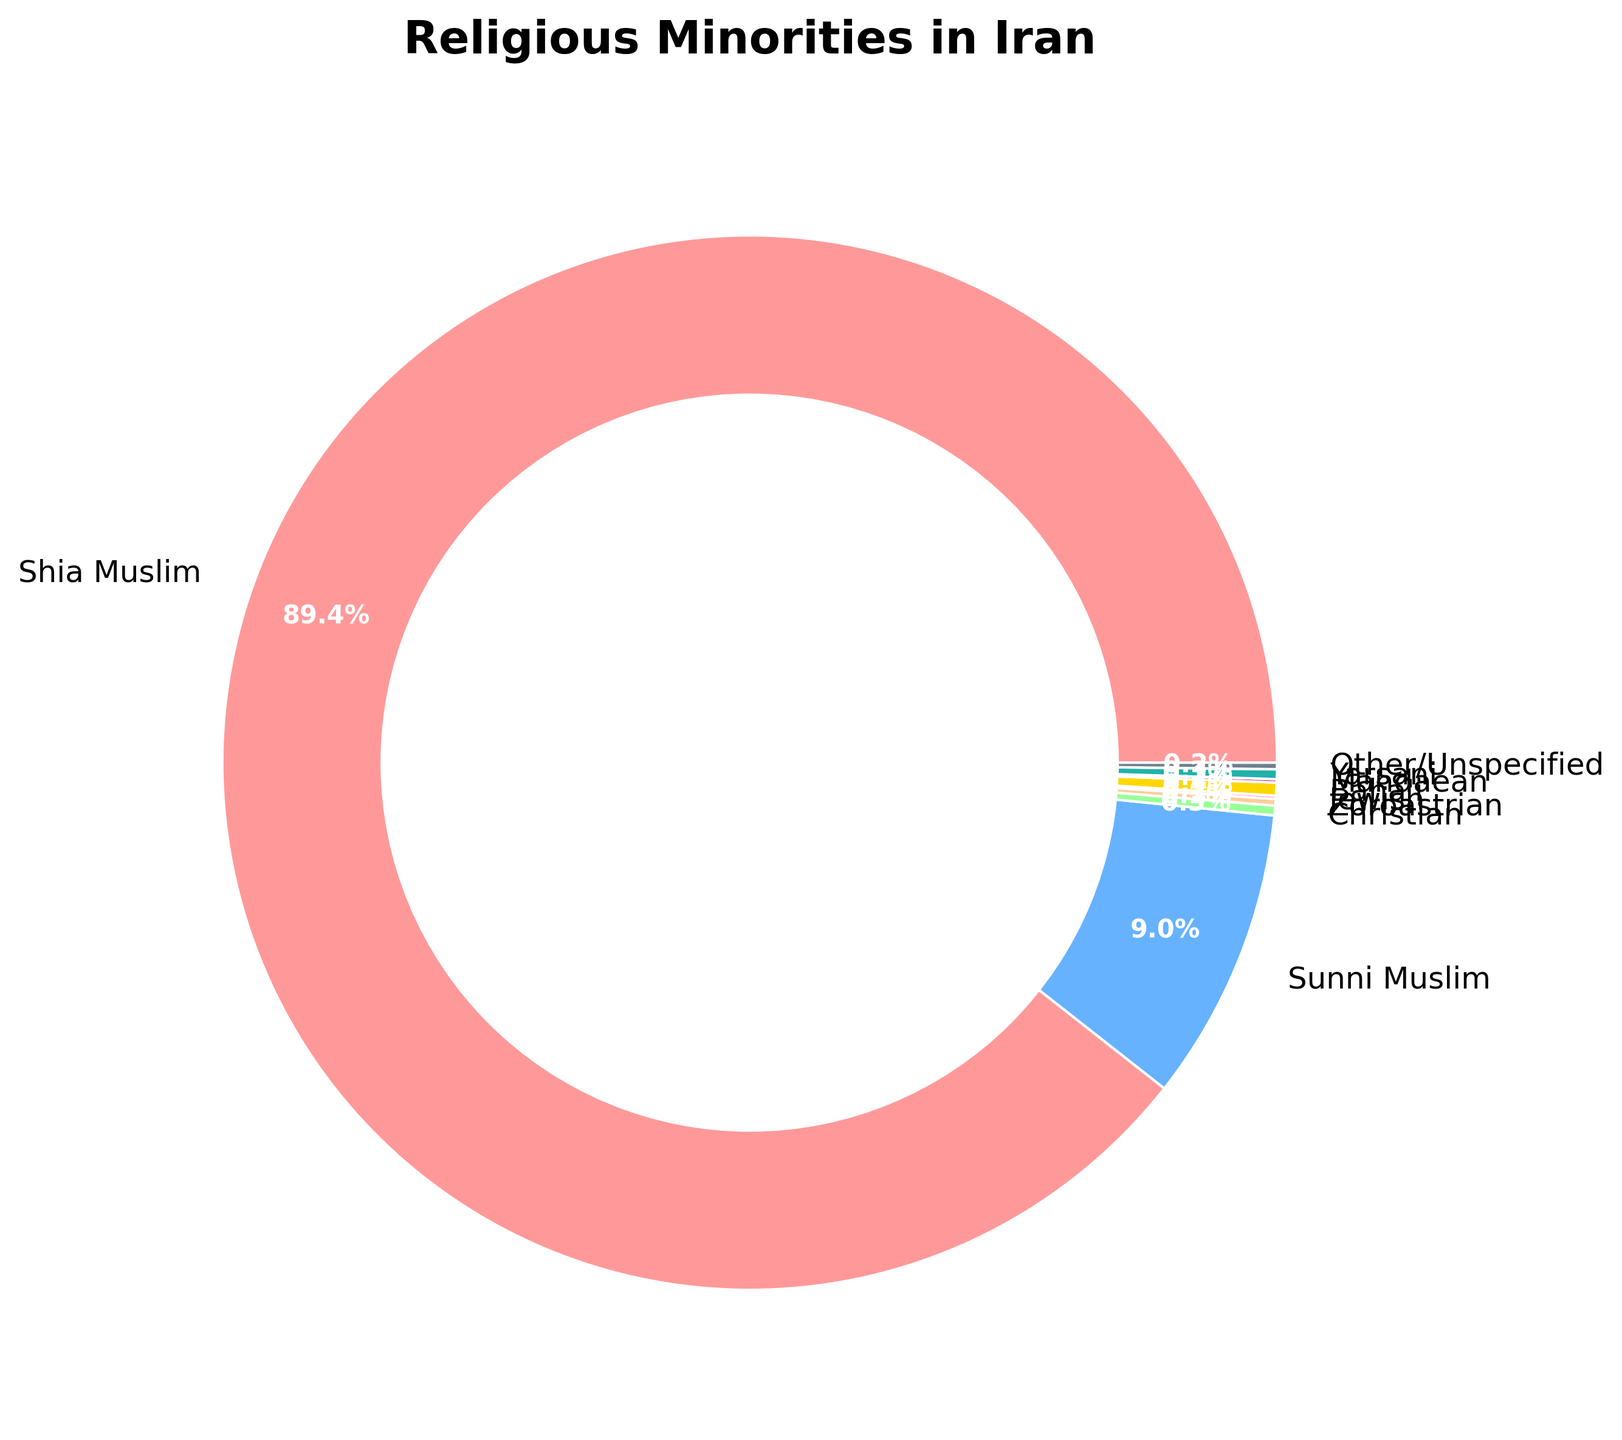What is the combined percentage of the Christian and Yarsani populations in Iran? Add the percentages of the Christian (0.3%) and Yarsani (0.3%) populations. Therefore, 0.3% + 0.3% = 0.6%.
Answer: 0.6% Which religious minority has the smallest representation in Iran? By examining the percentages, the smallest are tied between the Jewish and Mandaean populations, both at 0.1%.
Answer: Jewish and Mandaean Is the percentage of Sunni Muslims in Iran greater than the combined percentage of all other religious minorities? The percentage of Sunni Muslims is 9.0%. The combined percentage of all other religious minorities: Christian (0.3%) + Zoroastrian (0.2%) + Jewish (0.1%) + Baha'i (0.4%) + Mandaean (0.1%) + Yarsani (0.3%) + Other/Unspecified (0.2%) is 1.6%. Since 9.0% is greater than 1.6%, the Sunni percentage is greater.
Answer: Yes Which religious group has the largest wedge of the pie chart excluding Shia Muslims? Excluding Shia Muslims, the group with the largest wedge is the Sunni Muslims, making up 9.0%.
Answer: Sunni Muslims What colors are used to represent the Baha'i and Zoroastrian populations in the pie chart? The Baha'i population is represented by a yellow color, while the Zoroastrian population is represented by an orange color.
Answer: Yellow (Baha'i) and Orange (Zoroastrian) How many religious minorities have a representation of exactly 0.3% in Iran? From the data, the Christian and Yarsani populations each have a representation of 0.3%. Thus, there are two such minorities.
Answer: Two Among the religious minorities, which two have equal representation? Both the Jewish (0.1%) and Mandaean (0.1%) populations have equal representation.
Answer: Jewish and Mandaean Is the percentage of Baha'i more than the sum of Jewish and Mandaean populations? The Baha'i population is 0.4%, while the sum of Jewish (0.1%) and Mandaean (0.1%) populations is 0.2%. Since 0.4% is greater than 0.2%, the Baha'i percentage is more.
Answer: Yes What percentage of the population do the "Other/Unspecified" and "Zoroastrian" groups together constitute? Add the percentages of "Other/Unspecified" (0.2%) and Zoroastrian (0.2%) populations. Therefore, 0.2% + 0.2% = 0.4%.
Answer: 0.4% 